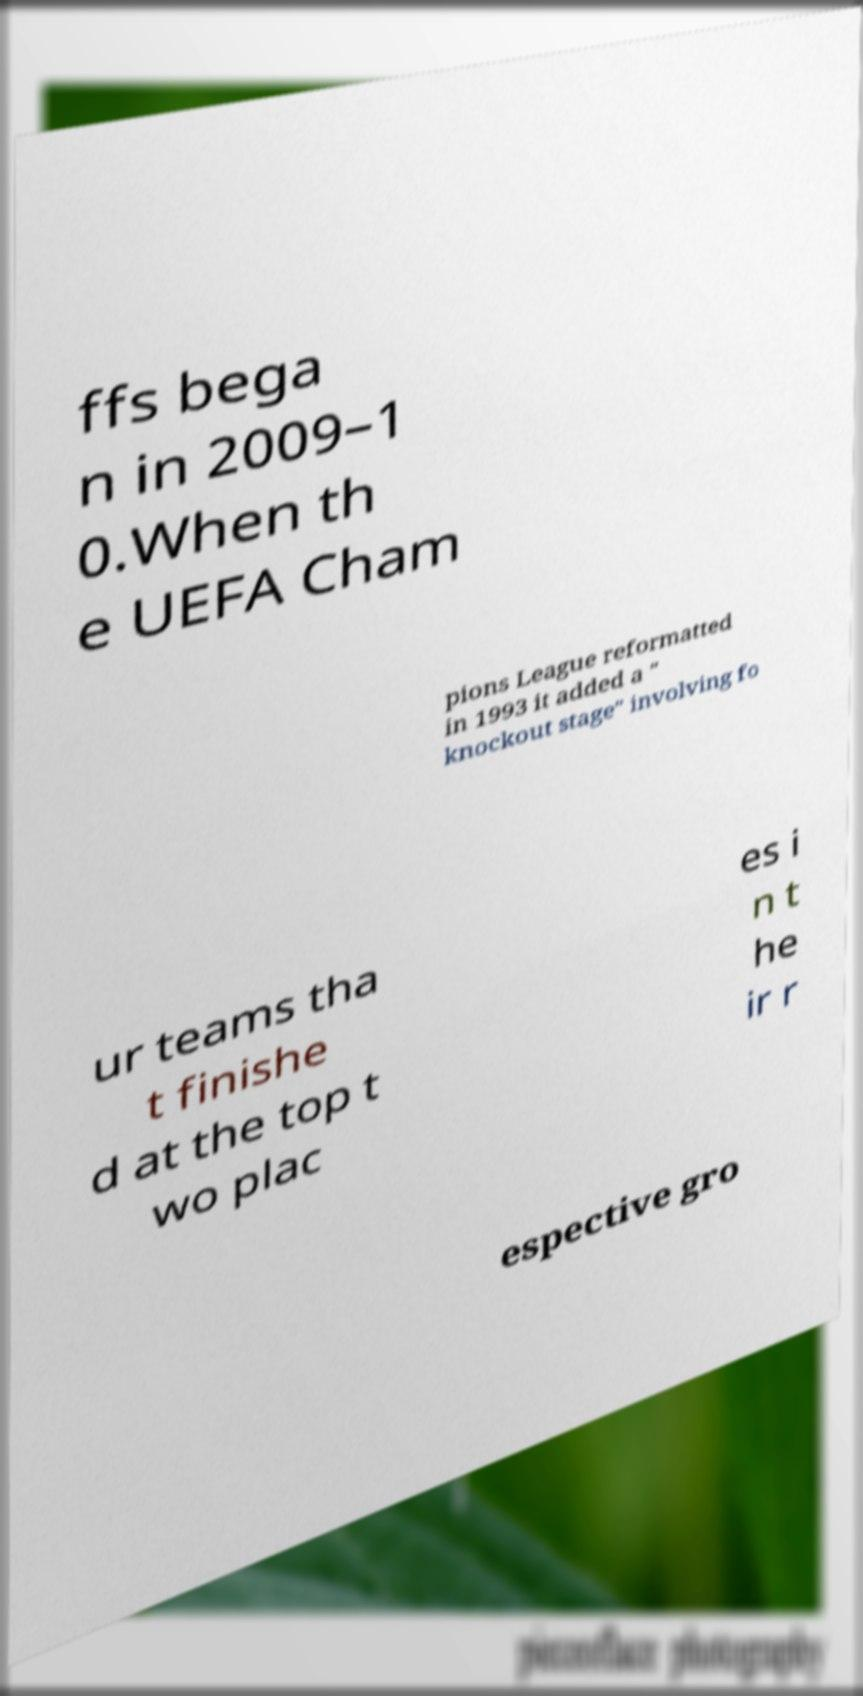Please read and relay the text visible in this image. What does it say? ffs bega n in 2009–1 0.When th e UEFA Cham pions League reformatted in 1993 it added a " knockout stage" involving fo ur teams tha t finishe d at the top t wo plac es i n t he ir r espective gro 